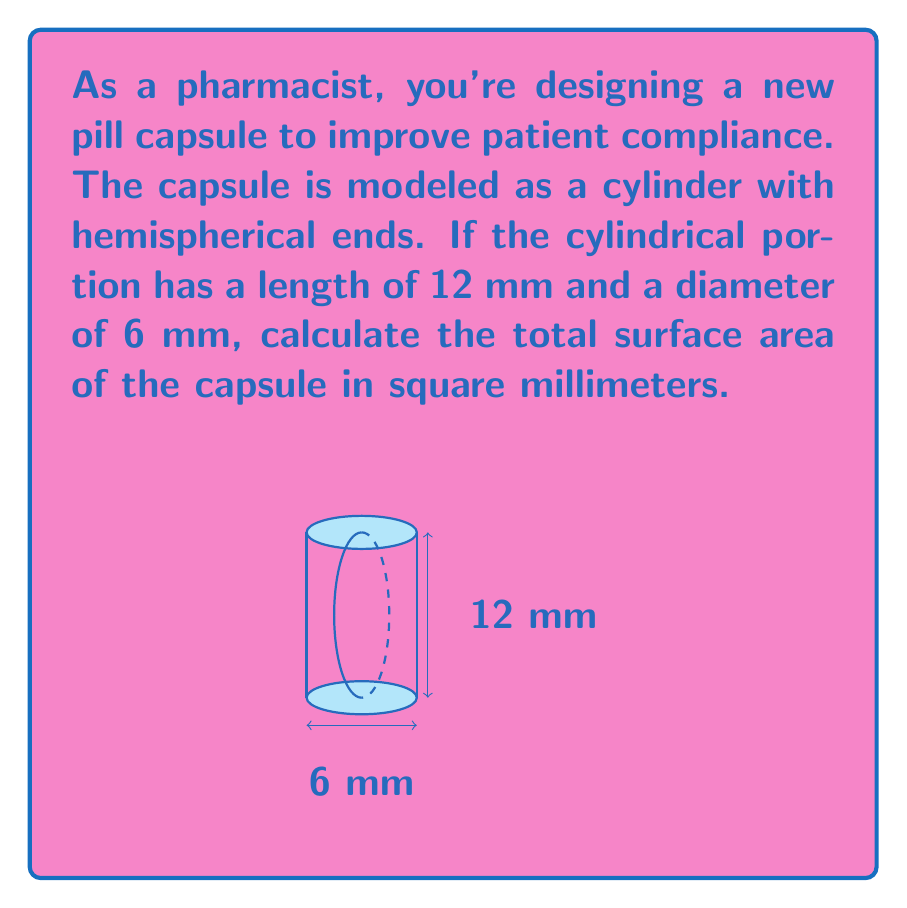Solve this math problem. Let's approach this step-by-step:

1) The capsule consists of three parts:
   - A cylindrical body
   - Two hemispherical ends

2) For the cylindrical part:
   - Radius $r = 3$ mm (half the diameter)
   - Height $h = 12$ mm
   - Surface area of cylinder (excluding ends) = $2\pi rh$
   $$A_{cylinder} = 2\pi (3)(12) = 72\pi \text{ mm}^2$$

3) For each hemispherical end:
   - Radius $r = 3$ mm
   - Surface area of a hemisphere = $2\pi r^2$
   $$A_{hemisphere} = 2\pi (3^2) = 18\pi \text{ mm}^2$$

4) Total surface area:
   $$\begin{align}
   A_{total} &= A_{cylinder} + 2A_{hemisphere} \\
   &= 72\pi + 2(18\pi) \\
   &= 72\pi + 36\pi \\
   &= 108\pi \text{ mm}^2
   \end{align}$$

5) Simplifying:
   $$108\pi \approx 339.29 \text{ mm}^2$$
Answer: $339.29 \text{ mm}^2$ 